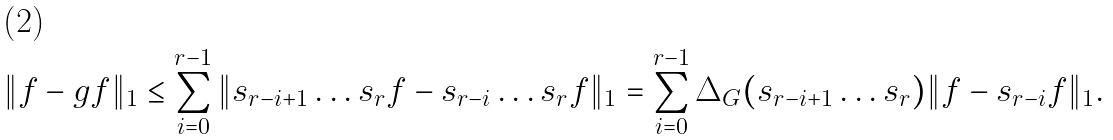Convert formula to latex. <formula><loc_0><loc_0><loc_500><loc_500>\| f - g f \| _ { 1 } \leq \sum _ { i = 0 } ^ { r - 1 } \| s _ { r - i + 1 } \dots s _ { r } f - s _ { r - i } \dots s _ { r } f \| _ { 1 } = \sum _ { i = 0 } ^ { r - 1 } \Delta _ { G } ( s _ { r - i + 1 } \dots s _ { r } ) \| f - s _ { r - i } f \| _ { 1 } .</formula> 